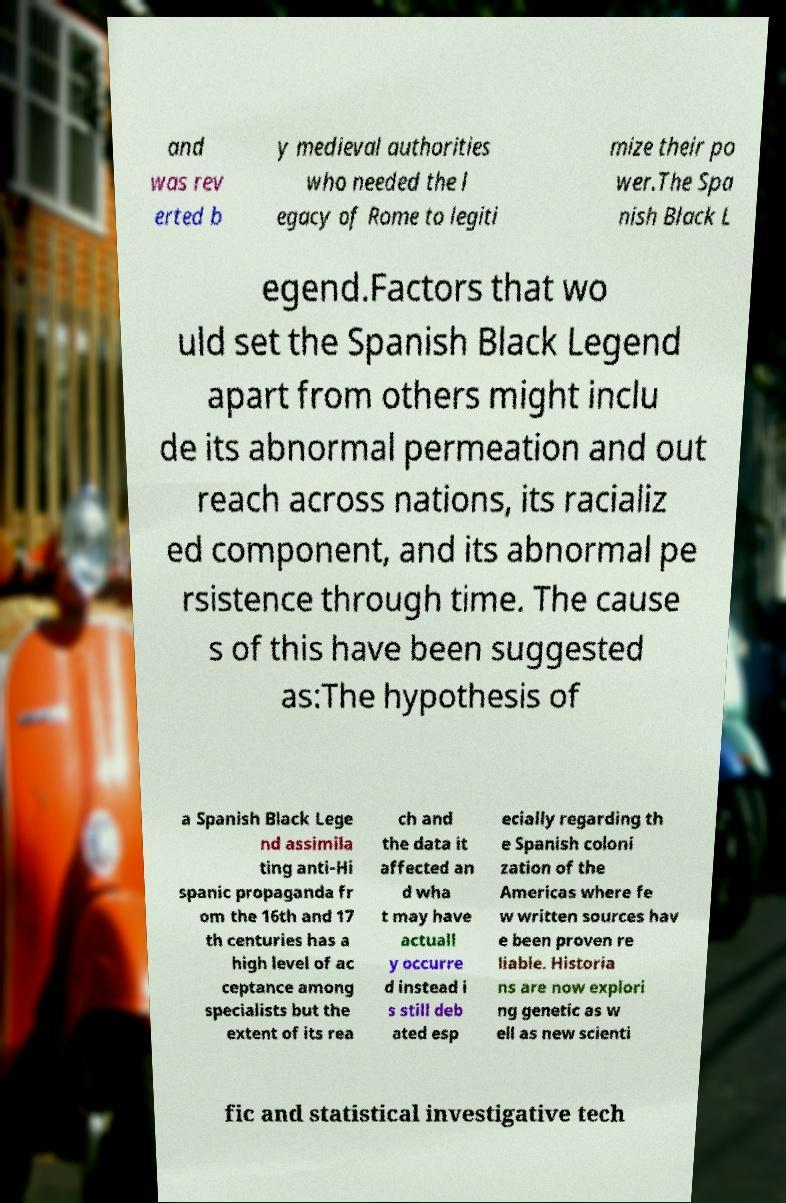There's text embedded in this image that I need extracted. Can you transcribe it verbatim? and was rev erted b y medieval authorities who needed the l egacy of Rome to legiti mize their po wer.The Spa nish Black L egend.Factors that wo uld set the Spanish Black Legend apart from others might inclu de its abnormal permeation and out reach across nations, its racializ ed component, and its abnormal pe rsistence through time. The cause s of this have been suggested as:The hypothesis of a Spanish Black Lege nd assimila ting anti-Hi spanic propaganda fr om the 16th and 17 th centuries has a high level of ac ceptance among specialists but the extent of its rea ch and the data it affected an d wha t may have actuall y occurre d instead i s still deb ated esp ecially regarding th e Spanish coloni zation of the Americas where fe w written sources hav e been proven re liable. Historia ns are now explori ng genetic as w ell as new scienti fic and statistical investigative tech 